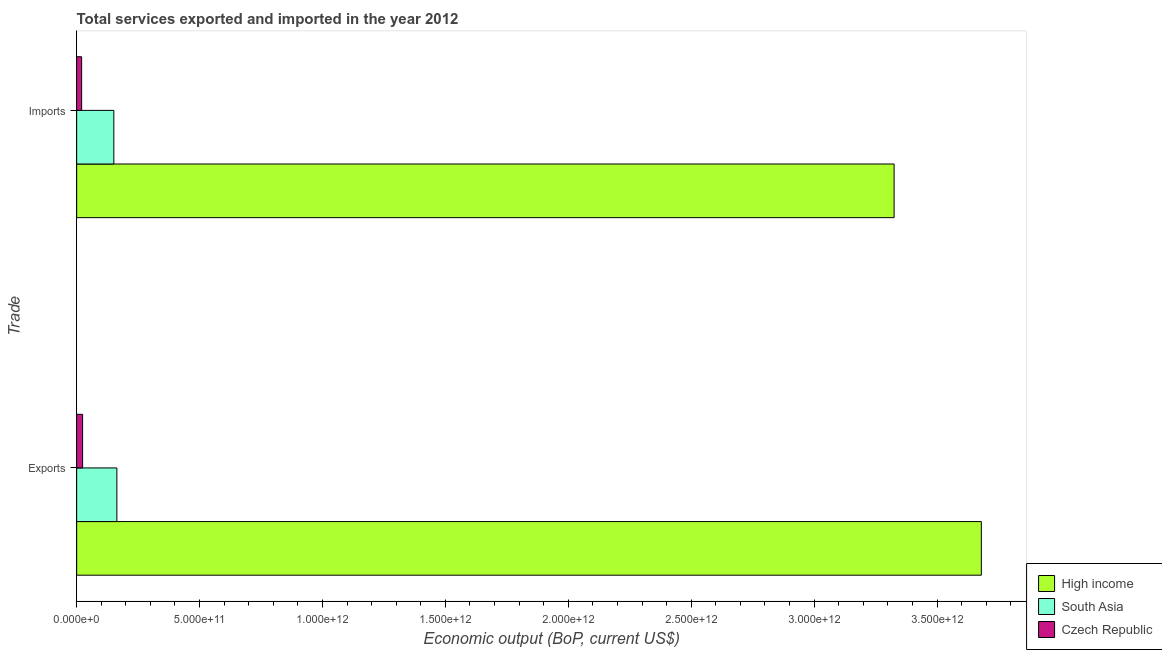How many different coloured bars are there?
Offer a very short reply. 3. How many groups of bars are there?
Make the answer very short. 2. Are the number of bars per tick equal to the number of legend labels?
Provide a short and direct response. Yes. How many bars are there on the 2nd tick from the bottom?
Offer a terse response. 3. What is the label of the 1st group of bars from the top?
Offer a terse response. Imports. What is the amount of service exports in High income?
Offer a very short reply. 3.68e+12. Across all countries, what is the maximum amount of service imports?
Give a very brief answer. 3.33e+12. Across all countries, what is the minimum amount of service exports?
Offer a terse response. 2.42e+1. In which country was the amount of service imports maximum?
Your answer should be compact. High income. In which country was the amount of service imports minimum?
Provide a short and direct response. Czech Republic. What is the total amount of service exports in the graph?
Ensure brevity in your answer.  3.87e+12. What is the difference between the amount of service exports in South Asia and that in Czech Republic?
Offer a terse response. 1.39e+11. What is the difference between the amount of service exports in South Asia and the amount of service imports in High income?
Provide a short and direct response. -3.16e+12. What is the average amount of service imports per country?
Keep it short and to the point. 1.17e+12. What is the difference between the amount of service exports and amount of service imports in South Asia?
Your answer should be very brief. 1.23e+1. What is the ratio of the amount of service imports in Czech Republic to that in South Asia?
Provide a short and direct response. 0.13. What does the 3rd bar from the top in Imports represents?
Provide a succinct answer. High income. What does the 3rd bar from the bottom in Exports represents?
Offer a very short reply. Czech Republic. How many bars are there?
Give a very brief answer. 6. How many countries are there in the graph?
Make the answer very short. 3. What is the difference between two consecutive major ticks on the X-axis?
Offer a very short reply. 5.00e+11. Are the values on the major ticks of X-axis written in scientific E-notation?
Ensure brevity in your answer.  Yes. Where does the legend appear in the graph?
Provide a short and direct response. Bottom right. What is the title of the graph?
Give a very brief answer. Total services exported and imported in the year 2012. What is the label or title of the X-axis?
Offer a terse response. Economic output (BoP, current US$). What is the label or title of the Y-axis?
Provide a short and direct response. Trade. What is the Economic output (BoP, current US$) in High income in Exports?
Make the answer very short. 3.68e+12. What is the Economic output (BoP, current US$) of South Asia in Exports?
Your answer should be compact. 1.64e+11. What is the Economic output (BoP, current US$) of Czech Republic in Exports?
Keep it short and to the point. 2.42e+1. What is the Economic output (BoP, current US$) in High income in Imports?
Make the answer very short. 3.33e+12. What is the Economic output (BoP, current US$) of South Asia in Imports?
Provide a succinct answer. 1.51e+11. What is the Economic output (BoP, current US$) of Czech Republic in Imports?
Your answer should be compact. 2.03e+1. Across all Trade, what is the maximum Economic output (BoP, current US$) in High income?
Give a very brief answer. 3.68e+12. Across all Trade, what is the maximum Economic output (BoP, current US$) of South Asia?
Ensure brevity in your answer.  1.64e+11. Across all Trade, what is the maximum Economic output (BoP, current US$) in Czech Republic?
Provide a succinct answer. 2.42e+1. Across all Trade, what is the minimum Economic output (BoP, current US$) in High income?
Your answer should be compact. 3.33e+12. Across all Trade, what is the minimum Economic output (BoP, current US$) in South Asia?
Provide a succinct answer. 1.51e+11. Across all Trade, what is the minimum Economic output (BoP, current US$) in Czech Republic?
Your answer should be compact. 2.03e+1. What is the total Economic output (BoP, current US$) of High income in the graph?
Your answer should be compact. 7.01e+12. What is the total Economic output (BoP, current US$) in South Asia in the graph?
Your answer should be compact. 3.15e+11. What is the total Economic output (BoP, current US$) in Czech Republic in the graph?
Your answer should be compact. 4.45e+1. What is the difference between the Economic output (BoP, current US$) in High income in Exports and that in Imports?
Keep it short and to the point. 3.55e+11. What is the difference between the Economic output (BoP, current US$) in South Asia in Exports and that in Imports?
Offer a terse response. 1.23e+1. What is the difference between the Economic output (BoP, current US$) of Czech Republic in Exports and that in Imports?
Provide a short and direct response. 3.97e+09. What is the difference between the Economic output (BoP, current US$) of High income in Exports and the Economic output (BoP, current US$) of South Asia in Imports?
Make the answer very short. 3.53e+12. What is the difference between the Economic output (BoP, current US$) of High income in Exports and the Economic output (BoP, current US$) of Czech Republic in Imports?
Ensure brevity in your answer.  3.66e+12. What is the difference between the Economic output (BoP, current US$) of South Asia in Exports and the Economic output (BoP, current US$) of Czech Republic in Imports?
Give a very brief answer. 1.43e+11. What is the average Economic output (BoP, current US$) of High income per Trade?
Ensure brevity in your answer.  3.50e+12. What is the average Economic output (BoP, current US$) of South Asia per Trade?
Your answer should be very brief. 1.57e+11. What is the average Economic output (BoP, current US$) in Czech Republic per Trade?
Provide a short and direct response. 2.23e+1. What is the difference between the Economic output (BoP, current US$) in High income and Economic output (BoP, current US$) in South Asia in Exports?
Your answer should be compact. 3.52e+12. What is the difference between the Economic output (BoP, current US$) of High income and Economic output (BoP, current US$) of Czech Republic in Exports?
Offer a very short reply. 3.66e+12. What is the difference between the Economic output (BoP, current US$) in South Asia and Economic output (BoP, current US$) in Czech Republic in Exports?
Make the answer very short. 1.39e+11. What is the difference between the Economic output (BoP, current US$) in High income and Economic output (BoP, current US$) in South Asia in Imports?
Your answer should be very brief. 3.17e+12. What is the difference between the Economic output (BoP, current US$) in High income and Economic output (BoP, current US$) in Czech Republic in Imports?
Offer a terse response. 3.31e+12. What is the difference between the Economic output (BoP, current US$) of South Asia and Economic output (BoP, current US$) of Czech Republic in Imports?
Your response must be concise. 1.31e+11. What is the ratio of the Economic output (BoP, current US$) of High income in Exports to that in Imports?
Your answer should be compact. 1.11. What is the ratio of the Economic output (BoP, current US$) in South Asia in Exports to that in Imports?
Give a very brief answer. 1.08. What is the ratio of the Economic output (BoP, current US$) of Czech Republic in Exports to that in Imports?
Your answer should be very brief. 1.2. What is the difference between the highest and the second highest Economic output (BoP, current US$) of High income?
Give a very brief answer. 3.55e+11. What is the difference between the highest and the second highest Economic output (BoP, current US$) of South Asia?
Ensure brevity in your answer.  1.23e+1. What is the difference between the highest and the second highest Economic output (BoP, current US$) of Czech Republic?
Make the answer very short. 3.97e+09. What is the difference between the highest and the lowest Economic output (BoP, current US$) in High income?
Provide a succinct answer. 3.55e+11. What is the difference between the highest and the lowest Economic output (BoP, current US$) of South Asia?
Your response must be concise. 1.23e+1. What is the difference between the highest and the lowest Economic output (BoP, current US$) in Czech Republic?
Keep it short and to the point. 3.97e+09. 